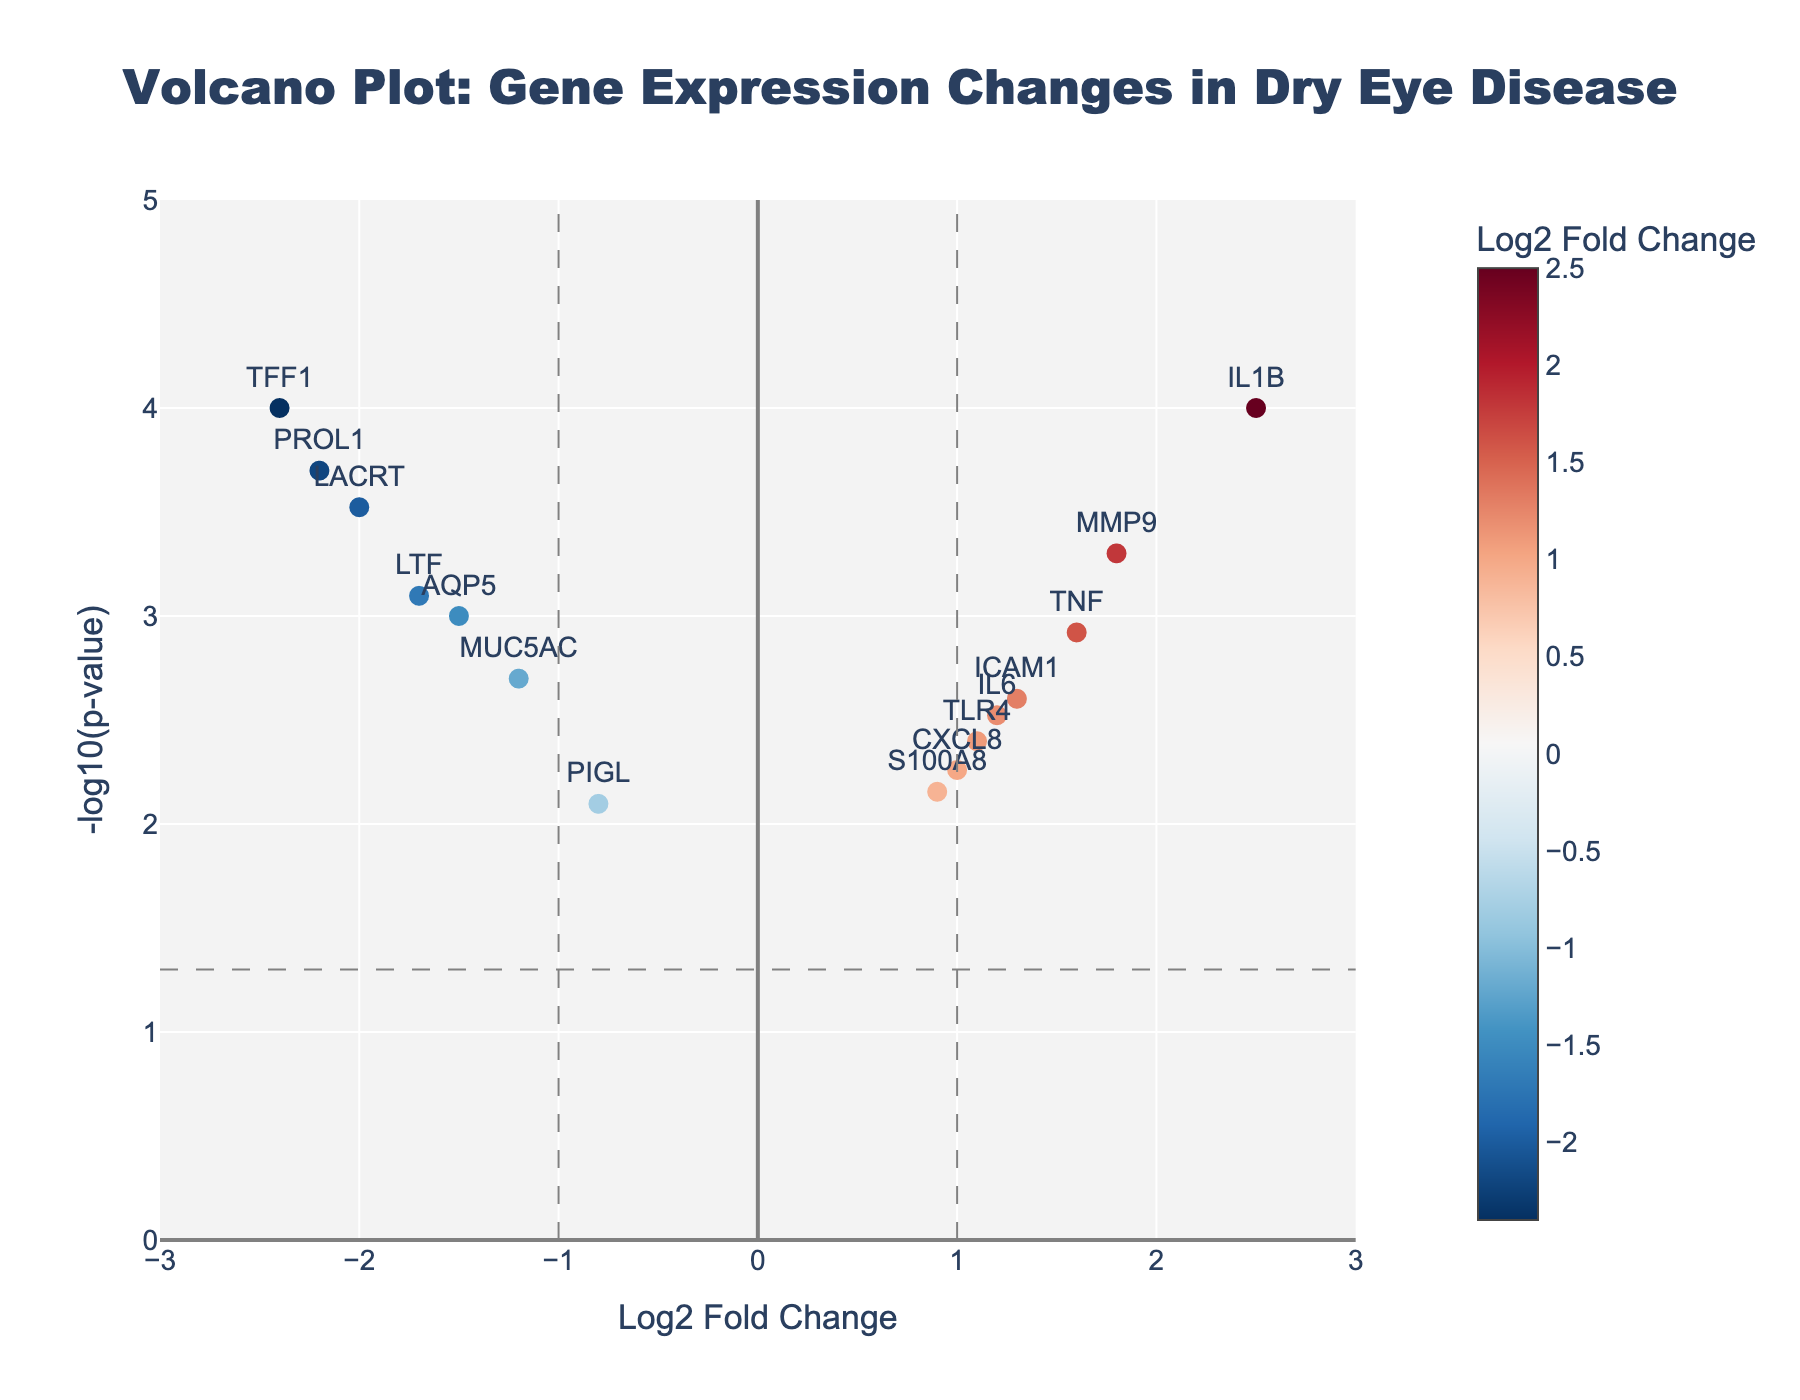What is the title of the figure? The title is typically displayed prominently at the top of the figure. In this case, it reads "Volcano Plot: Gene Expression Changes in Dry Eye Disease".
Answer: "Volcano Plot: Gene Expression Changes in Dry Eye Disease" What does the x-axis represent? The x-axis label provides this information. It is labeled "Log2 Fold Change", indicating it represents the log2 fold change in gene expression between dry eye disease patients and healthy controls.
Answer: Log2 Fold Change How many genes show a log2 fold change greater than 1? To determine this, count the number of data points (genes) that have an x-axis value (Log2 Fold Change) greater than 1. The genes are IL1B and MMP9.
Answer: 2 Which gene has the highest -log10(p-value)? Look for the data point with the highest y-axis value (representing -log10(p-value)). This gene is IL1B.
Answer: IL1B Which gene has the lowest log2 fold change? Identify the gene with the lowest x-axis value (Log2 Fold Change). The gene is TFF1.
Answer: TFF1 How many genes have a p-value lower than 0.001? To find this, look for data points above the y-axis value corresponding to -log10(0.001). The genes above this value are IL1B, LACRT, and PROL1.
Answer: 3 What are the names of the genes with a log2 fold change less than -1 and a p-value less than 0.05? Look for data points to the left of the -1 mark on the x-axis and above the horizontal line for -log10(0.05). These genes are MUC5AC, AQP5, LTF, LACRT, PROL1, and TFF1.
Answer: MUC5AC, AQP5, LTF, LACRT, PROL1, TFF1 Are there any genes with a log2 fold change between -1 and 1 that have a significant p-value (p < 0.05)? Look for points within the range of -1 to 1 on the x-axis that are above the horizontal line for -log10(0.05). The genes are ICAM1, IL6, TLR4, and CXCL8.
Answer: ICAM1, IL6, TLR4, CXCL8 